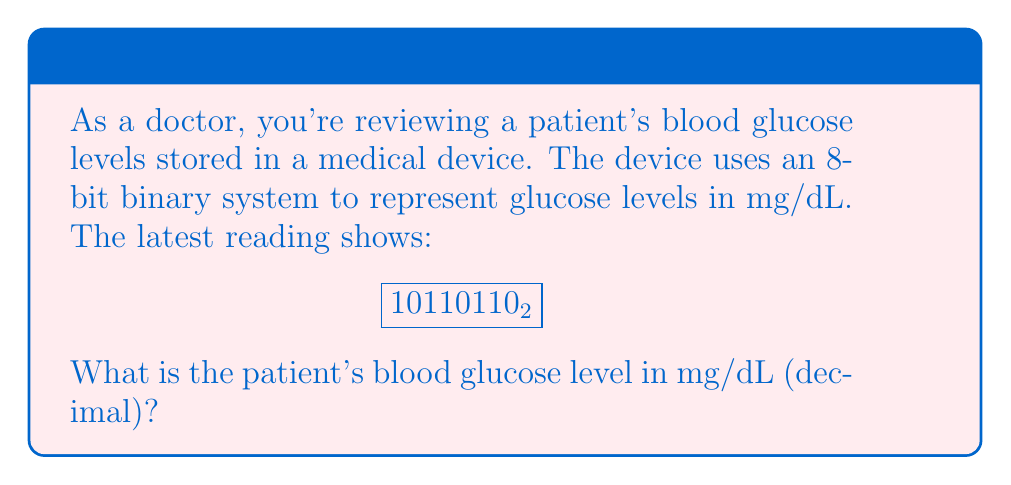Help me with this question. To convert the binary number to decimal, we need to follow these steps:

1) First, let's write out the place values for an 8-bit binary number:

   $$2^7, 2^6, 2^5, 2^4, 2^3, 2^2, 2^1, 2^0$$

2) Now, let's align our binary number with these place values:

   $$
   \begin{array}{r}
   2^7 & 2^6 & 2^5 & 2^4 & 2^3 & 2^2 & 2^1 & 2^0 \\
   1 & 0 & 1 & 1 & 0 & 1 & 1 & 0
   \end{array}
   $$

3) We only sum the place values where there's a 1 in the binary number:

   $$2^7 + 2^5 + 2^4 + 2^2 + 2^1$$

4) Let's calculate each of these:

   $$128 + 32 + 16 + 4 + 2$$

5) Sum these values:

   $$128 + 32 + 16 + 4 + 2 = 182$$

Therefore, the blood glucose level represented by $10110110_2$ is 182 mg/dL.
Answer: 182 mg/dL 